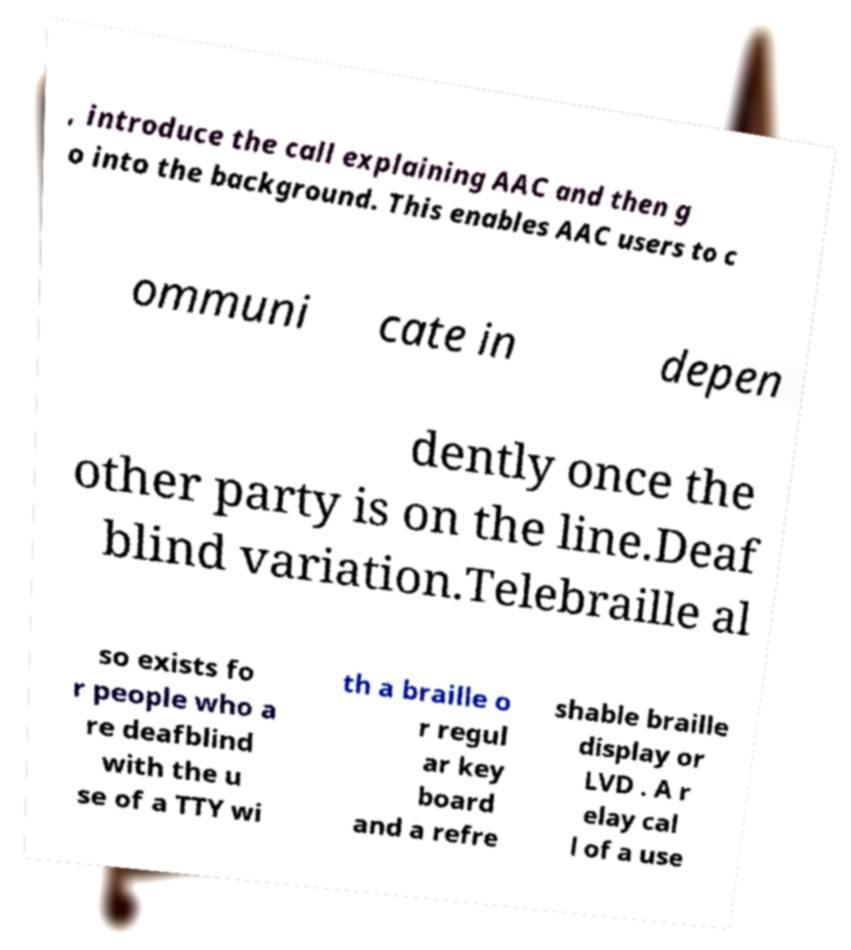Please identify and transcribe the text found in this image. , introduce the call explaining AAC and then g o into the background. This enables AAC users to c ommuni cate in depen dently once the other party is on the line.Deaf blind variation.Telebraille al so exists fo r people who a re deafblind with the u se of a TTY wi th a braille o r regul ar key board and a refre shable braille display or LVD . A r elay cal l of a use 